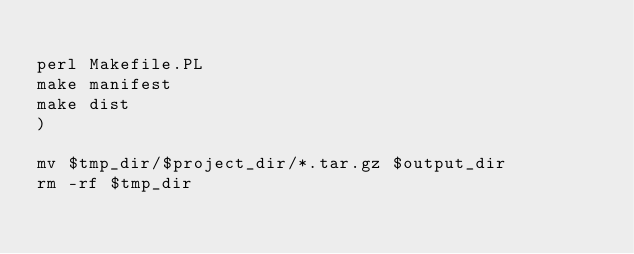Convert code to text. <code><loc_0><loc_0><loc_500><loc_500><_Bash_>
perl Makefile.PL
make manifest
make dist
)

mv $tmp_dir/$project_dir/*.tar.gz $output_dir
rm -rf $tmp_dir
</code> 